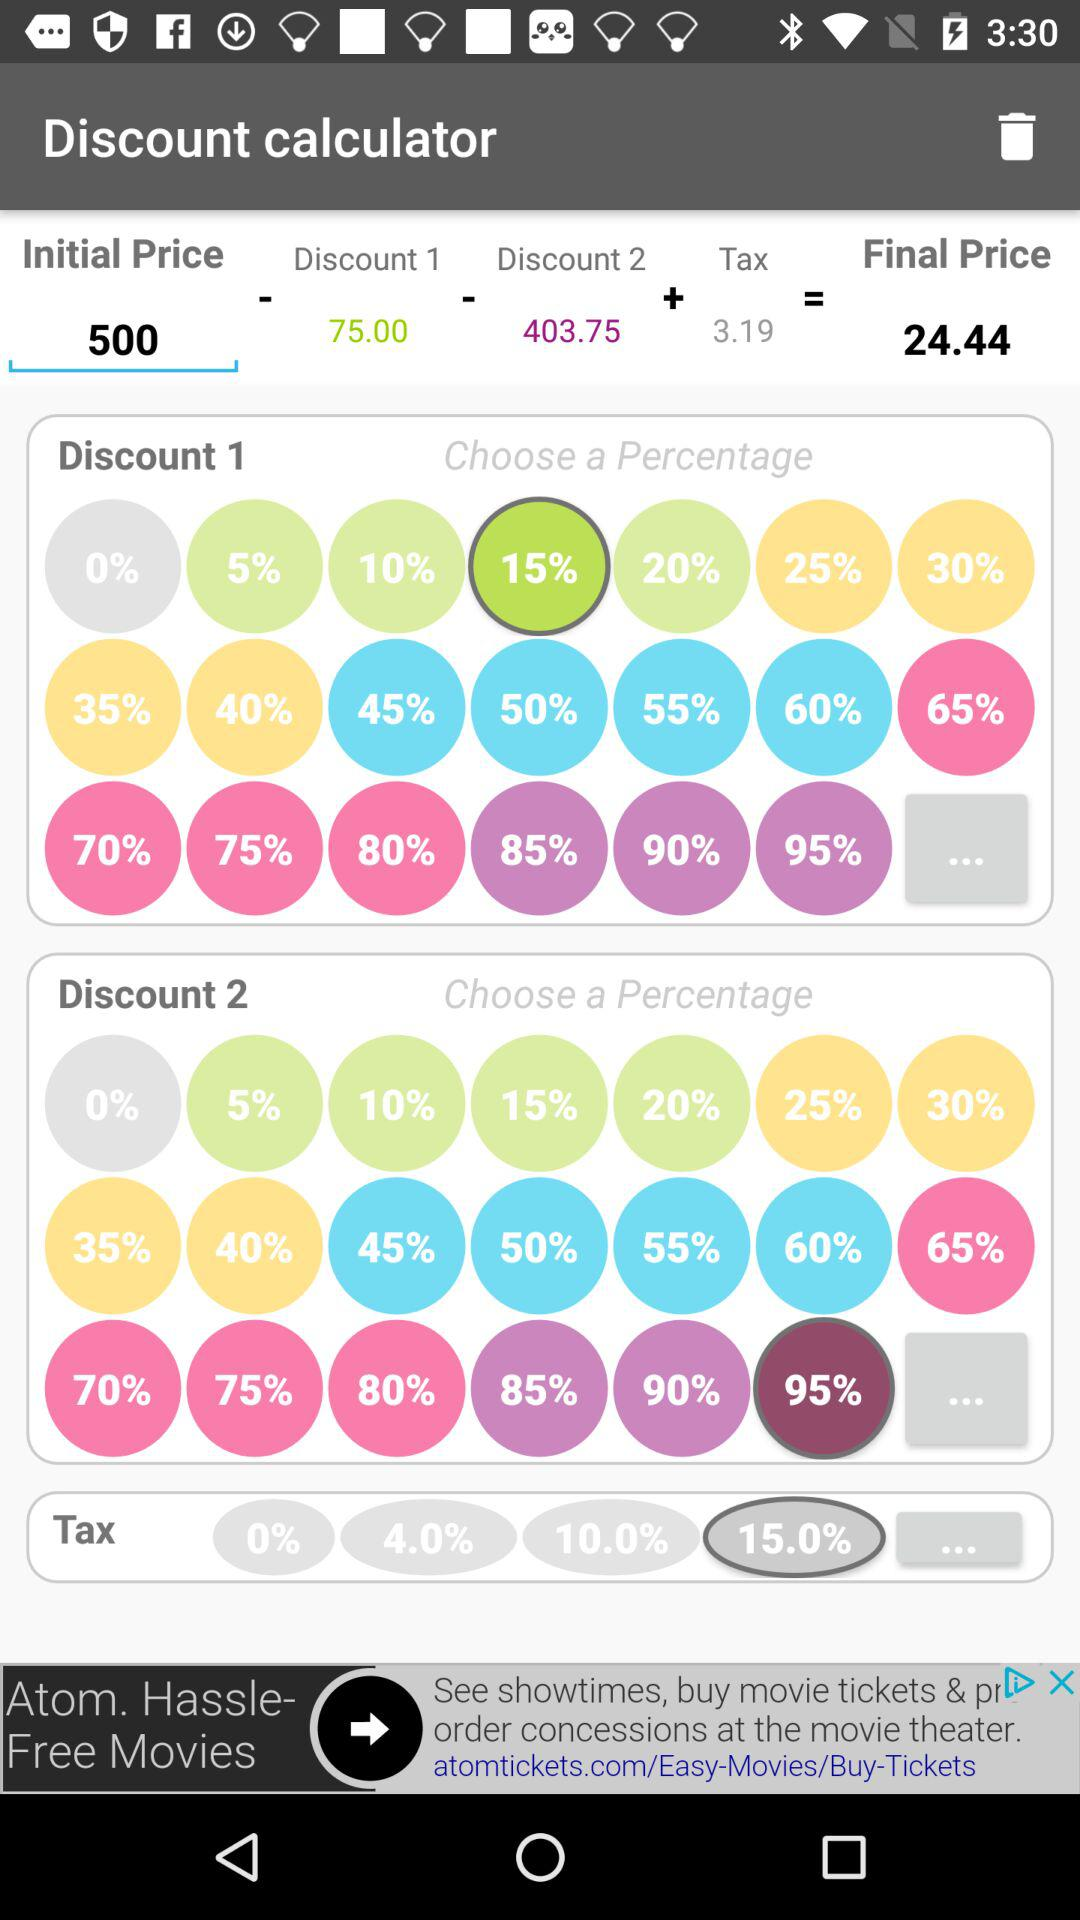What's the final price? The final price is 24.44. 